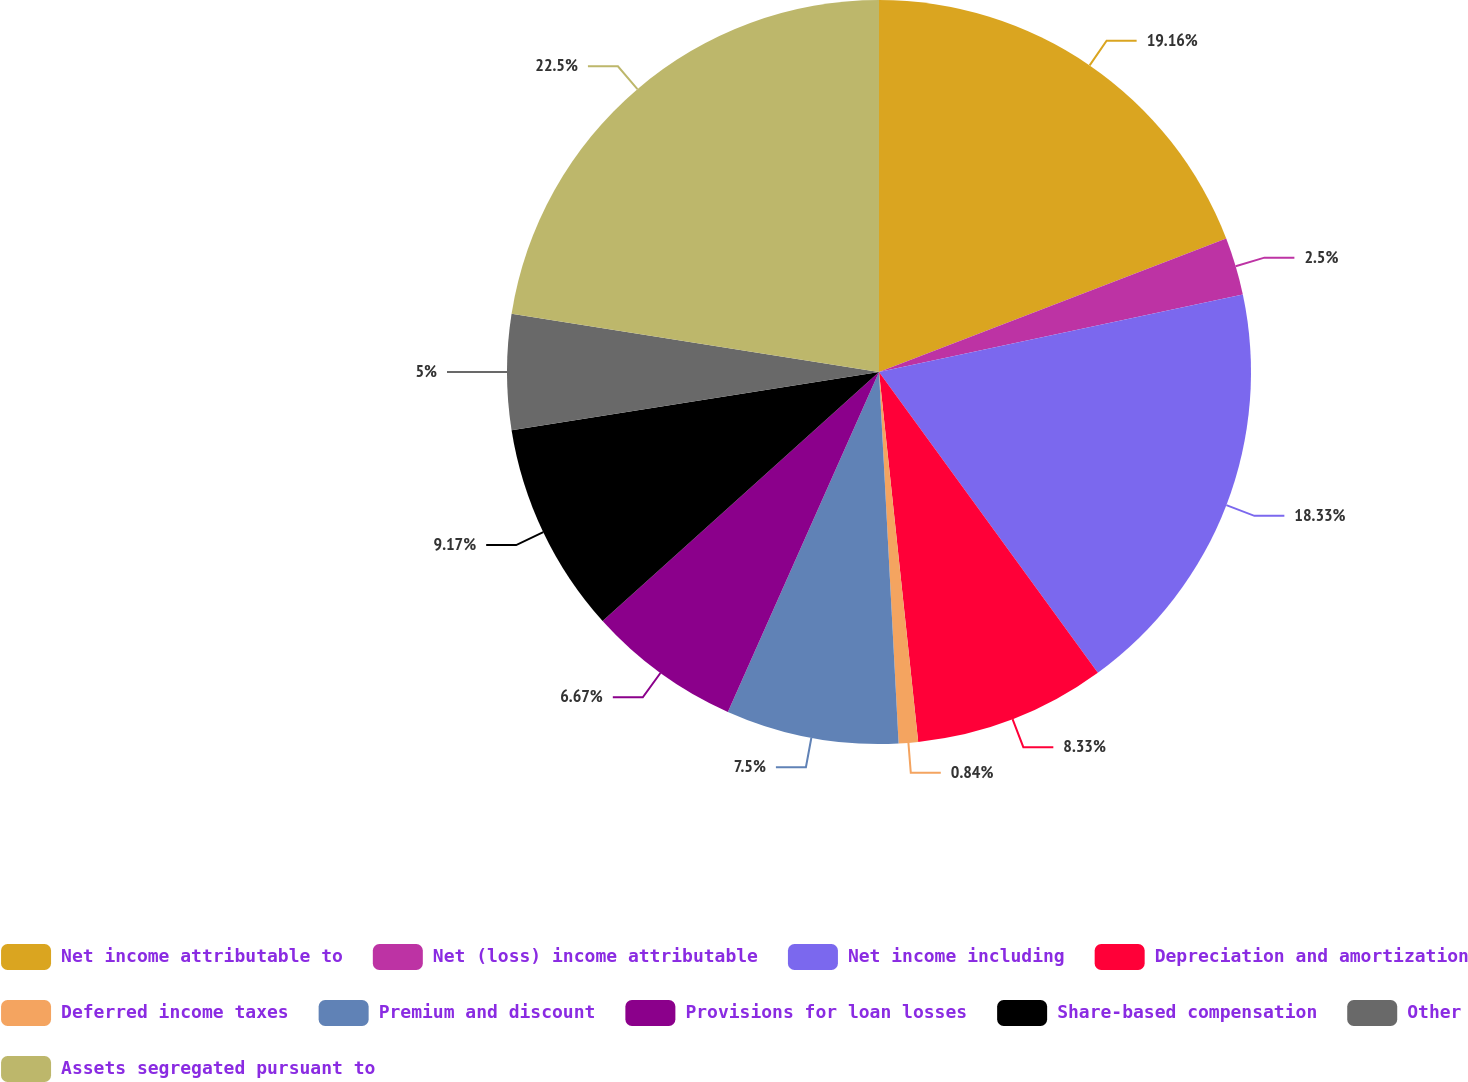Convert chart. <chart><loc_0><loc_0><loc_500><loc_500><pie_chart><fcel>Net income attributable to<fcel>Net (loss) income attributable<fcel>Net income including<fcel>Depreciation and amortization<fcel>Deferred income taxes<fcel>Premium and discount<fcel>Provisions for loan losses<fcel>Share-based compensation<fcel>Other<fcel>Assets segregated pursuant to<nl><fcel>19.16%<fcel>2.5%<fcel>18.33%<fcel>8.33%<fcel>0.84%<fcel>7.5%<fcel>6.67%<fcel>9.17%<fcel>5.0%<fcel>22.5%<nl></chart> 